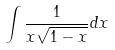<formula> <loc_0><loc_0><loc_500><loc_500>\int \frac { 1 } { x \sqrt { 1 - x } } d x</formula> 